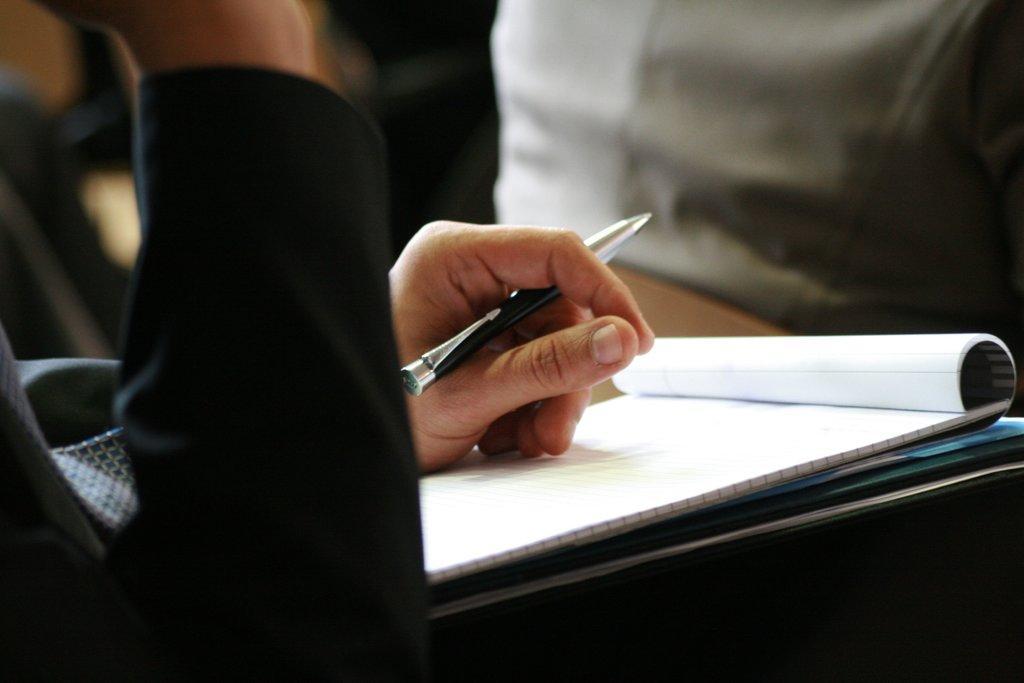Please provide a concise description of this image. It is a hand of a human being holding a pen this is a book. 